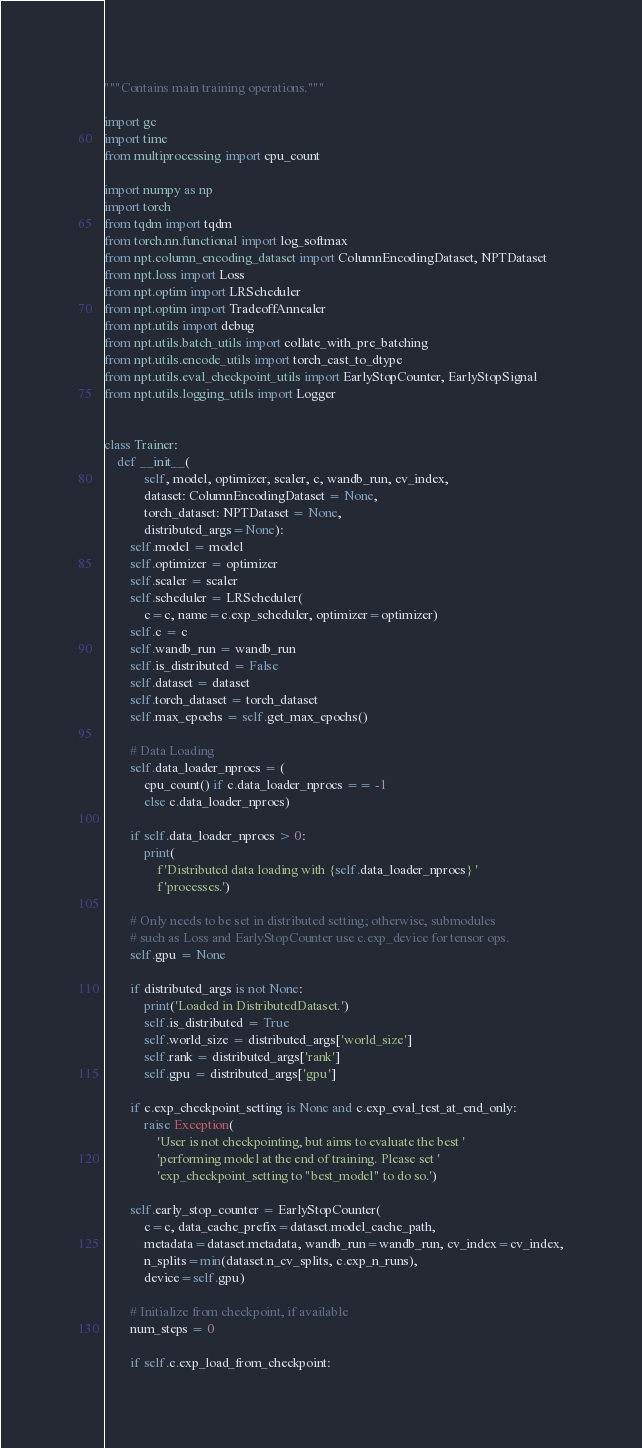<code> <loc_0><loc_0><loc_500><loc_500><_Python_>"""Contains main training operations."""

import gc
import time
from multiprocessing import cpu_count

import numpy as np
import torch
from tqdm import tqdm
from torch.nn.functional import log_softmax
from npt.column_encoding_dataset import ColumnEncodingDataset, NPTDataset
from npt.loss import Loss
from npt.optim import LRScheduler
from npt.optim import TradeoffAnnealer
from npt.utils import debug
from npt.utils.batch_utils import collate_with_pre_batching
from npt.utils.encode_utils import torch_cast_to_dtype
from npt.utils.eval_checkpoint_utils import EarlyStopCounter, EarlyStopSignal
from npt.utils.logging_utils import Logger


class Trainer:
    def __init__(
            self, model, optimizer, scaler, c, wandb_run, cv_index,
            dataset: ColumnEncodingDataset = None,
            torch_dataset: NPTDataset = None,
            distributed_args=None):
        self.model = model
        self.optimizer = optimizer
        self.scaler = scaler
        self.scheduler = LRScheduler(
            c=c, name=c.exp_scheduler, optimizer=optimizer)
        self.c = c
        self.wandb_run = wandb_run
        self.is_distributed = False
        self.dataset = dataset
        self.torch_dataset = torch_dataset
        self.max_epochs = self.get_max_epochs()

        # Data Loading
        self.data_loader_nprocs = (
            cpu_count() if c.data_loader_nprocs == -1
            else c.data_loader_nprocs)

        if self.data_loader_nprocs > 0:
            print(
                f'Distributed data loading with {self.data_loader_nprocs} '
                f'processes.')

        # Only needs to be set in distributed setting; otherwise, submodules
        # such as Loss and EarlyStopCounter use c.exp_device for tensor ops.
        self.gpu = None

        if distributed_args is not None:
            print('Loaded in DistributedDataset.')
            self.is_distributed = True
            self.world_size = distributed_args['world_size']
            self.rank = distributed_args['rank']
            self.gpu = distributed_args['gpu']

        if c.exp_checkpoint_setting is None and c.exp_eval_test_at_end_only:
            raise Exception(
                'User is not checkpointing, but aims to evaluate the best '
                'performing model at the end of training. Please set '
                'exp_checkpoint_setting to "best_model" to do so.')

        self.early_stop_counter = EarlyStopCounter(
            c=c, data_cache_prefix=dataset.model_cache_path,
            metadata=dataset.metadata, wandb_run=wandb_run, cv_index=cv_index,
            n_splits=min(dataset.n_cv_splits, c.exp_n_runs),
            device=self.gpu)

        # Initialize from checkpoint, if available
        num_steps = 0

        if self.c.exp_load_from_checkpoint:</code> 